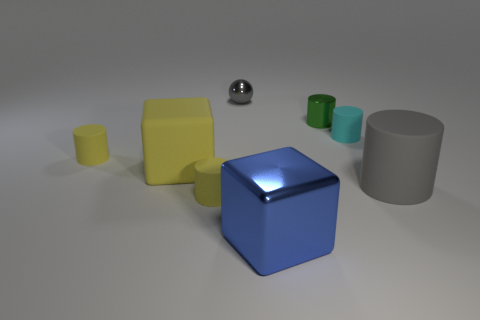Add 1 tiny cylinders. How many objects exist? 9 Subtract all small cyan cylinders. How many cylinders are left? 4 Subtract all green blocks. How many yellow cylinders are left? 2 Subtract 1 blocks. How many blocks are left? 1 Subtract all cylinders. How many objects are left? 3 Subtract all gray cylinders. How many cylinders are left? 4 Add 8 green rubber cylinders. How many green rubber cylinders exist? 8 Subtract 0 cyan cubes. How many objects are left? 8 Subtract all gray cylinders. Subtract all red cubes. How many cylinders are left? 4 Subtract all large yellow rubber blocks. Subtract all red shiny cylinders. How many objects are left? 7 